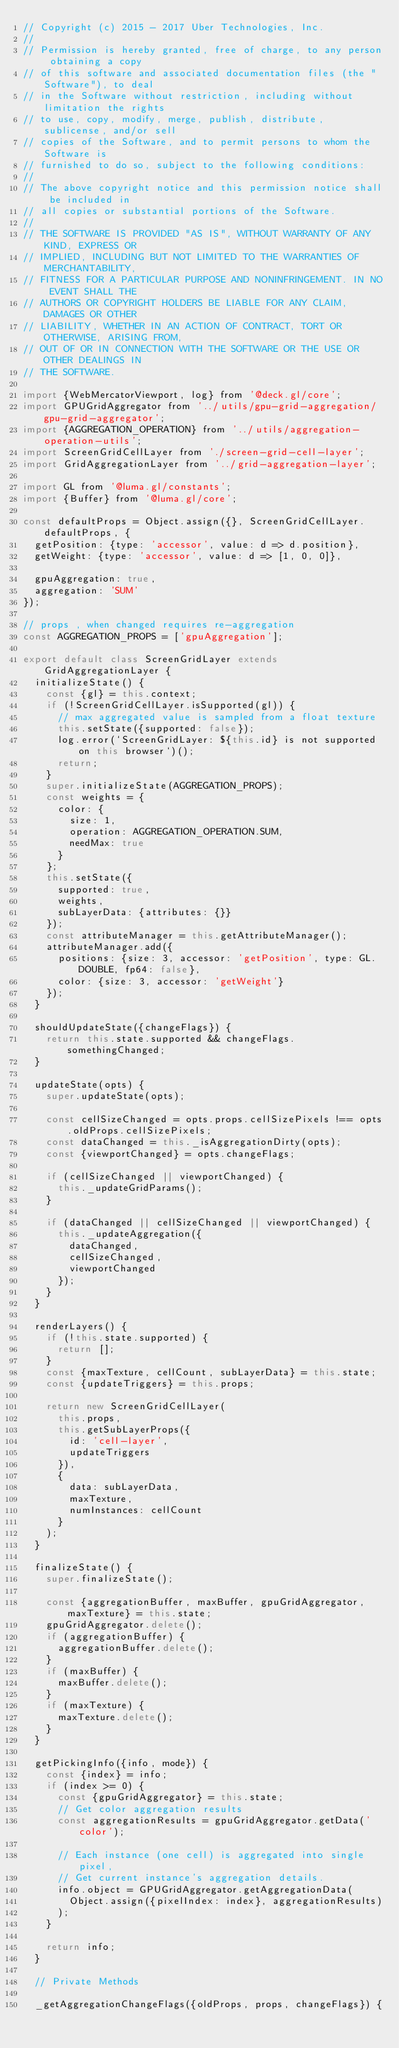<code> <loc_0><loc_0><loc_500><loc_500><_JavaScript_>// Copyright (c) 2015 - 2017 Uber Technologies, Inc.
//
// Permission is hereby granted, free of charge, to any person obtaining a copy
// of this software and associated documentation files (the "Software"), to deal
// in the Software without restriction, including without limitation the rights
// to use, copy, modify, merge, publish, distribute, sublicense, and/or sell
// copies of the Software, and to permit persons to whom the Software is
// furnished to do so, subject to the following conditions:
//
// The above copyright notice and this permission notice shall be included in
// all copies or substantial portions of the Software.
//
// THE SOFTWARE IS PROVIDED "AS IS", WITHOUT WARRANTY OF ANY KIND, EXPRESS OR
// IMPLIED, INCLUDING BUT NOT LIMITED TO THE WARRANTIES OF MERCHANTABILITY,
// FITNESS FOR A PARTICULAR PURPOSE AND NONINFRINGEMENT. IN NO EVENT SHALL THE
// AUTHORS OR COPYRIGHT HOLDERS BE LIABLE FOR ANY CLAIM, DAMAGES OR OTHER
// LIABILITY, WHETHER IN AN ACTION OF CONTRACT, TORT OR OTHERWISE, ARISING FROM,
// OUT OF OR IN CONNECTION WITH THE SOFTWARE OR THE USE OR OTHER DEALINGS IN
// THE SOFTWARE.

import {WebMercatorViewport, log} from '@deck.gl/core';
import GPUGridAggregator from '../utils/gpu-grid-aggregation/gpu-grid-aggregator';
import {AGGREGATION_OPERATION} from '../utils/aggregation-operation-utils';
import ScreenGridCellLayer from './screen-grid-cell-layer';
import GridAggregationLayer from '../grid-aggregation-layer';

import GL from '@luma.gl/constants';
import {Buffer} from '@luma.gl/core';

const defaultProps = Object.assign({}, ScreenGridCellLayer.defaultProps, {
  getPosition: {type: 'accessor', value: d => d.position},
  getWeight: {type: 'accessor', value: d => [1, 0, 0]},

  gpuAggregation: true,
  aggregation: 'SUM'
});

// props , when changed requires re-aggregation
const AGGREGATION_PROPS = ['gpuAggregation'];

export default class ScreenGridLayer extends GridAggregationLayer {
  initializeState() {
    const {gl} = this.context;
    if (!ScreenGridCellLayer.isSupported(gl)) {
      // max aggregated value is sampled from a float texture
      this.setState({supported: false});
      log.error(`ScreenGridLayer: ${this.id} is not supported on this browser`)();
      return;
    }
    super.initializeState(AGGREGATION_PROPS);
    const weights = {
      color: {
        size: 1,
        operation: AGGREGATION_OPERATION.SUM,
        needMax: true
      }
    };
    this.setState({
      supported: true,
      weights,
      subLayerData: {attributes: {}}
    });
    const attributeManager = this.getAttributeManager();
    attributeManager.add({
      positions: {size: 3, accessor: 'getPosition', type: GL.DOUBLE, fp64: false},
      color: {size: 3, accessor: 'getWeight'}
    });
  }

  shouldUpdateState({changeFlags}) {
    return this.state.supported && changeFlags.somethingChanged;
  }

  updateState(opts) {
    super.updateState(opts);

    const cellSizeChanged = opts.props.cellSizePixels !== opts.oldProps.cellSizePixels;
    const dataChanged = this._isAggregationDirty(opts);
    const {viewportChanged} = opts.changeFlags;

    if (cellSizeChanged || viewportChanged) {
      this._updateGridParams();
    }

    if (dataChanged || cellSizeChanged || viewportChanged) {
      this._updateAggregation({
        dataChanged,
        cellSizeChanged,
        viewportChanged
      });
    }
  }

  renderLayers() {
    if (!this.state.supported) {
      return [];
    }
    const {maxTexture, cellCount, subLayerData} = this.state;
    const {updateTriggers} = this.props;

    return new ScreenGridCellLayer(
      this.props,
      this.getSubLayerProps({
        id: 'cell-layer',
        updateTriggers
      }),
      {
        data: subLayerData,
        maxTexture,
        numInstances: cellCount
      }
    );
  }

  finalizeState() {
    super.finalizeState();

    const {aggregationBuffer, maxBuffer, gpuGridAggregator, maxTexture} = this.state;
    gpuGridAggregator.delete();
    if (aggregationBuffer) {
      aggregationBuffer.delete();
    }
    if (maxBuffer) {
      maxBuffer.delete();
    }
    if (maxTexture) {
      maxTexture.delete();
    }
  }

  getPickingInfo({info, mode}) {
    const {index} = info;
    if (index >= 0) {
      const {gpuGridAggregator} = this.state;
      // Get color aggregation results
      const aggregationResults = gpuGridAggregator.getData('color');

      // Each instance (one cell) is aggregated into single pixel,
      // Get current instance's aggregation details.
      info.object = GPUGridAggregator.getAggregationData(
        Object.assign({pixelIndex: index}, aggregationResults)
      );
    }

    return info;
  }

  // Private Methods

  _getAggregationChangeFlags({oldProps, props, changeFlags}) {</code> 